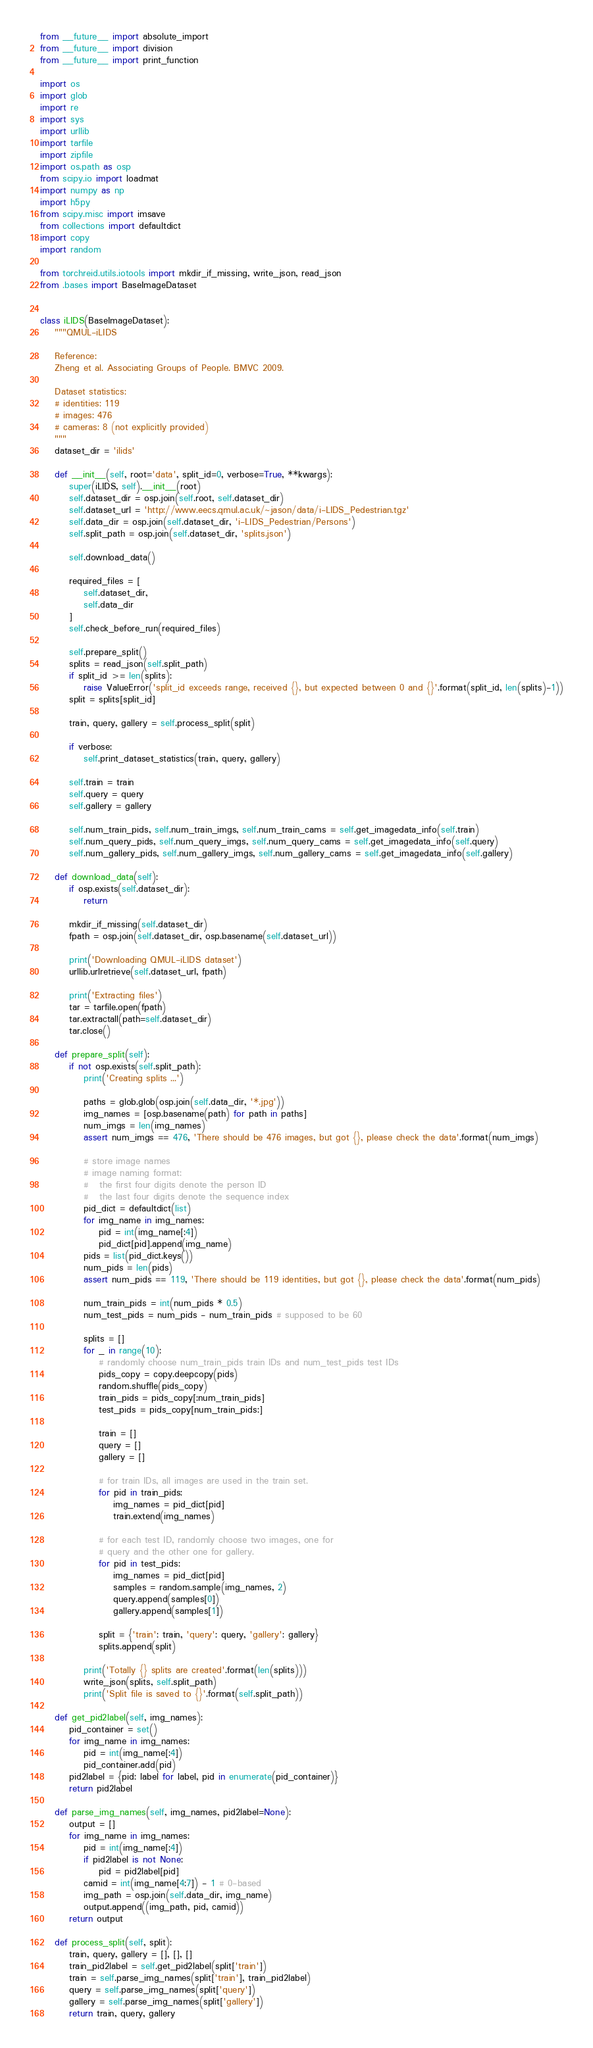Convert code to text. <code><loc_0><loc_0><loc_500><loc_500><_Python_>from __future__ import absolute_import
from __future__ import division
from __future__ import print_function

import os
import glob
import re
import sys
import urllib
import tarfile
import zipfile
import os.path as osp
from scipy.io import loadmat
import numpy as np
import h5py
from scipy.misc import imsave
from collections import defaultdict
import copy
import random

from torchreid.utils.iotools import mkdir_if_missing, write_json, read_json
from .bases import BaseImageDataset


class iLIDS(BaseImageDataset):
    """QMUL-iLIDS

    Reference:
    Zheng et al. Associating Groups of People. BMVC 2009.
    
    Dataset statistics:
    # identities: 119
    # images: 476
    # cameras: 8 (not explicitly provided)
    """
    dataset_dir = 'ilids'

    def __init__(self, root='data', split_id=0, verbose=True, **kwargs):
        super(iLIDS, self).__init__(root)
        self.dataset_dir = osp.join(self.root, self.dataset_dir)
        self.dataset_url = 'http://www.eecs.qmul.ac.uk/~jason/data/i-LIDS_Pedestrian.tgz'
        self.data_dir = osp.join(self.dataset_dir, 'i-LIDS_Pedestrian/Persons')
        self.split_path = osp.join(self.dataset_dir, 'splits.json')

        self.download_data()
        
        required_files = [
            self.dataset_dir,
            self.data_dir
        ]
        self.check_before_run(required_files)

        self.prepare_split()
        splits = read_json(self.split_path)
        if split_id >= len(splits):
            raise ValueError('split_id exceeds range, received {}, but expected between 0 and {}'.format(split_id, len(splits)-1))
        split = splits[split_id]

        train, query, gallery = self.process_split(split)

        if verbose:
            self.print_dataset_statistics(train, query, gallery)

        self.train = train
        self.query = query
        self.gallery = gallery

        self.num_train_pids, self.num_train_imgs, self.num_train_cams = self.get_imagedata_info(self.train)
        self.num_query_pids, self.num_query_imgs, self.num_query_cams = self.get_imagedata_info(self.query)
        self.num_gallery_pids, self.num_gallery_imgs, self.num_gallery_cams = self.get_imagedata_info(self.gallery)

    def download_data(self):
        if osp.exists(self.dataset_dir):
            return

        mkdir_if_missing(self.dataset_dir)
        fpath = osp.join(self.dataset_dir, osp.basename(self.dataset_url))

        print('Downloading QMUL-iLIDS dataset')
        urllib.urlretrieve(self.dataset_url, fpath)

        print('Extracting files')
        tar = tarfile.open(fpath)
        tar.extractall(path=self.dataset_dir)
        tar.close()

    def prepare_split(self):
        if not osp.exists(self.split_path):
            print('Creating splits ...')
            
            paths = glob.glob(osp.join(self.data_dir, '*.jpg'))
            img_names = [osp.basename(path) for path in paths]
            num_imgs = len(img_names)
            assert num_imgs == 476, 'There should be 476 images, but got {}, please check the data'.format(num_imgs)

            # store image names
            # image naming format:
            #   the first four digits denote the person ID
            #   the last four digits denote the sequence index
            pid_dict = defaultdict(list)
            for img_name in img_names:
                pid = int(img_name[:4])
                pid_dict[pid].append(img_name)
            pids = list(pid_dict.keys())
            num_pids = len(pids)
            assert num_pids == 119, 'There should be 119 identities, but got {}, please check the data'.format(num_pids)

            num_train_pids = int(num_pids * 0.5)
            num_test_pids = num_pids - num_train_pids # supposed to be 60

            splits = []
            for _ in range(10):
                # randomly choose num_train_pids train IDs and num_test_pids test IDs
                pids_copy = copy.deepcopy(pids)
                random.shuffle(pids_copy)
                train_pids = pids_copy[:num_train_pids]
                test_pids = pids_copy[num_train_pids:]

                train = []
                query = []
                gallery = []

                # for train IDs, all images are used in the train set.
                for pid in train_pids:
                    img_names = pid_dict[pid]
                    train.extend(img_names)

                # for each test ID, randomly choose two images, one for
                # query and the other one for gallery.
                for pid in test_pids:
                    img_names = pid_dict[pid]
                    samples = random.sample(img_names, 2)
                    query.append(samples[0])
                    gallery.append(samples[1])

                split = {'train': train, 'query': query, 'gallery': gallery}
                splits.append(split)

            print('Totally {} splits are created'.format(len(splits)))
            write_json(splits, self.split_path)
            print('Split file is saved to {}'.format(self.split_path))

    def get_pid2label(self, img_names):
        pid_container = set()
        for img_name in img_names:
            pid = int(img_name[:4])
            pid_container.add(pid)
        pid2label = {pid: label for label, pid in enumerate(pid_container)}
        return pid2label

    def parse_img_names(self, img_names, pid2label=None):
        output = []
        for img_name in img_names:
            pid = int(img_name[:4])
            if pid2label is not None:
                pid = pid2label[pid]
            camid = int(img_name[4:7]) - 1 # 0-based
            img_path = osp.join(self.data_dir, img_name)
            output.append((img_path, pid, camid))
        return output

    def process_split(self, split):
        train, query, gallery = [], [], []
        train_pid2label = self.get_pid2label(split['train'])
        train = self.parse_img_names(split['train'], train_pid2label)
        query = self.parse_img_names(split['query'])
        gallery = self.parse_img_names(split['gallery'])
        return train, query, gallery</code> 